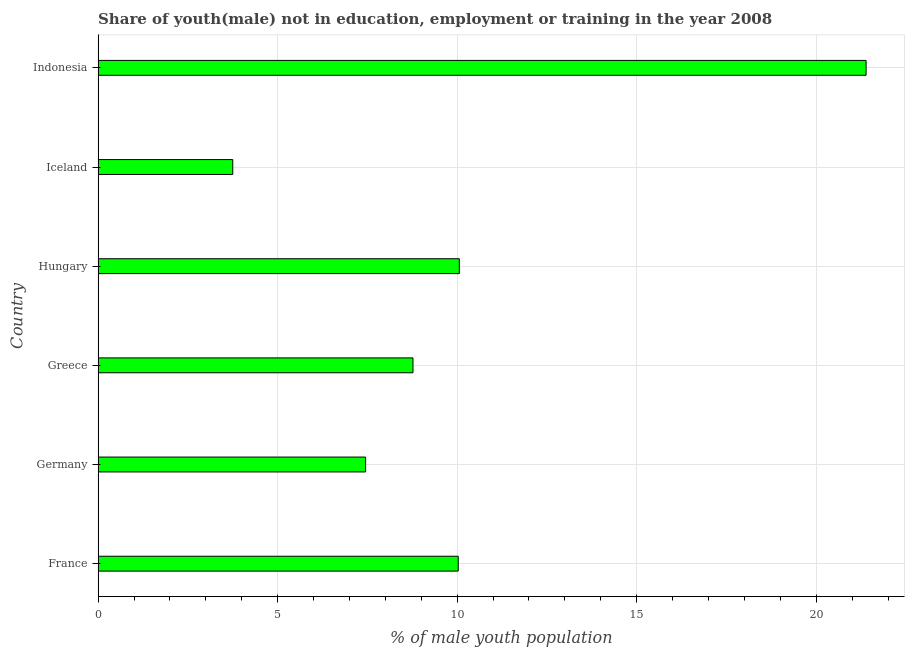Does the graph contain grids?
Your answer should be very brief. Yes. What is the title of the graph?
Your answer should be very brief. Share of youth(male) not in education, employment or training in the year 2008. What is the label or title of the X-axis?
Your answer should be very brief. % of male youth population. What is the unemployed male youth population in Hungary?
Ensure brevity in your answer.  10.06. Across all countries, what is the maximum unemployed male youth population?
Offer a very short reply. 21.39. Across all countries, what is the minimum unemployed male youth population?
Offer a very short reply. 3.75. What is the sum of the unemployed male youth population?
Keep it short and to the point. 61.45. What is the difference between the unemployed male youth population in France and Germany?
Provide a succinct answer. 2.58. What is the average unemployed male youth population per country?
Provide a succinct answer. 10.24. What is the median unemployed male youth population?
Offer a very short reply. 9.4. In how many countries, is the unemployed male youth population greater than 15 %?
Your answer should be very brief. 1. What is the ratio of the unemployed male youth population in France to that in Germany?
Make the answer very short. 1.35. Is the difference between the unemployed male youth population in France and Hungary greater than the difference between any two countries?
Give a very brief answer. No. What is the difference between the highest and the second highest unemployed male youth population?
Your response must be concise. 11.33. Is the sum of the unemployed male youth population in France and Germany greater than the maximum unemployed male youth population across all countries?
Your answer should be very brief. No. What is the difference between the highest and the lowest unemployed male youth population?
Your answer should be compact. 17.64. In how many countries, is the unemployed male youth population greater than the average unemployed male youth population taken over all countries?
Keep it short and to the point. 1. How many bars are there?
Make the answer very short. 6. Are all the bars in the graph horizontal?
Offer a very short reply. Yes. What is the difference between two consecutive major ticks on the X-axis?
Offer a very short reply. 5. What is the % of male youth population of France?
Keep it short and to the point. 10.03. What is the % of male youth population of Germany?
Your answer should be very brief. 7.45. What is the % of male youth population in Greece?
Keep it short and to the point. 8.77. What is the % of male youth population of Hungary?
Your answer should be compact. 10.06. What is the % of male youth population in Iceland?
Your answer should be compact. 3.75. What is the % of male youth population in Indonesia?
Provide a succinct answer. 21.39. What is the difference between the % of male youth population in France and Germany?
Give a very brief answer. 2.58. What is the difference between the % of male youth population in France and Greece?
Offer a terse response. 1.26. What is the difference between the % of male youth population in France and Hungary?
Your answer should be compact. -0.03. What is the difference between the % of male youth population in France and Iceland?
Keep it short and to the point. 6.28. What is the difference between the % of male youth population in France and Indonesia?
Make the answer very short. -11.36. What is the difference between the % of male youth population in Germany and Greece?
Ensure brevity in your answer.  -1.32. What is the difference between the % of male youth population in Germany and Hungary?
Offer a very short reply. -2.61. What is the difference between the % of male youth population in Germany and Indonesia?
Give a very brief answer. -13.94. What is the difference between the % of male youth population in Greece and Hungary?
Make the answer very short. -1.29. What is the difference between the % of male youth population in Greece and Iceland?
Provide a succinct answer. 5.02. What is the difference between the % of male youth population in Greece and Indonesia?
Provide a short and direct response. -12.62. What is the difference between the % of male youth population in Hungary and Iceland?
Make the answer very short. 6.31. What is the difference between the % of male youth population in Hungary and Indonesia?
Your answer should be compact. -11.33. What is the difference between the % of male youth population in Iceland and Indonesia?
Your answer should be compact. -17.64. What is the ratio of the % of male youth population in France to that in Germany?
Ensure brevity in your answer.  1.35. What is the ratio of the % of male youth population in France to that in Greece?
Offer a very short reply. 1.14. What is the ratio of the % of male youth population in France to that in Hungary?
Provide a short and direct response. 1. What is the ratio of the % of male youth population in France to that in Iceland?
Your answer should be compact. 2.67. What is the ratio of the % of male youth population in France to that in Indonesia?
Keep it short and to the point. 0.47. What is the ratio of the % of male youth population in Germany to that in Greece?
Ensure brevity in your answer.  0.85. What is the ratio of the % of male youth population in Germany to that in Hungary?
Ensure brevity in your answer.  0.74. What is the ratio of the % of male youth population in Germany to that in Iceland?
Offer a very short reply. 1.99. What is the ratio of the % of male youth population in Germany to that in Indonesia?
Keep it short and to the point. 0.35. What is the ratio of the % of male youth population in Greece to that in Hungary?
Ensure brevity in your answer.  0.87. What is the ratio of the % of male youth population in Greece to that in Iceland?
Provide a short and direct response. 2.34. What is the ratio of the % of male youth population in Greece to that in Indonesia?
Give a very brief answer. 0.41. What is the ratio of the % of male youth population in Hungary to that in Iceland?
Make the answer very short. 2.68. What is the ratio of the % of male youth population in Hungary to that in Indonesia?
Your answer should be compact. 0.47. What is the ratio of the % of male youth population in Iceland to that in Indonesia?
Offer a very short reply. 0.17. 